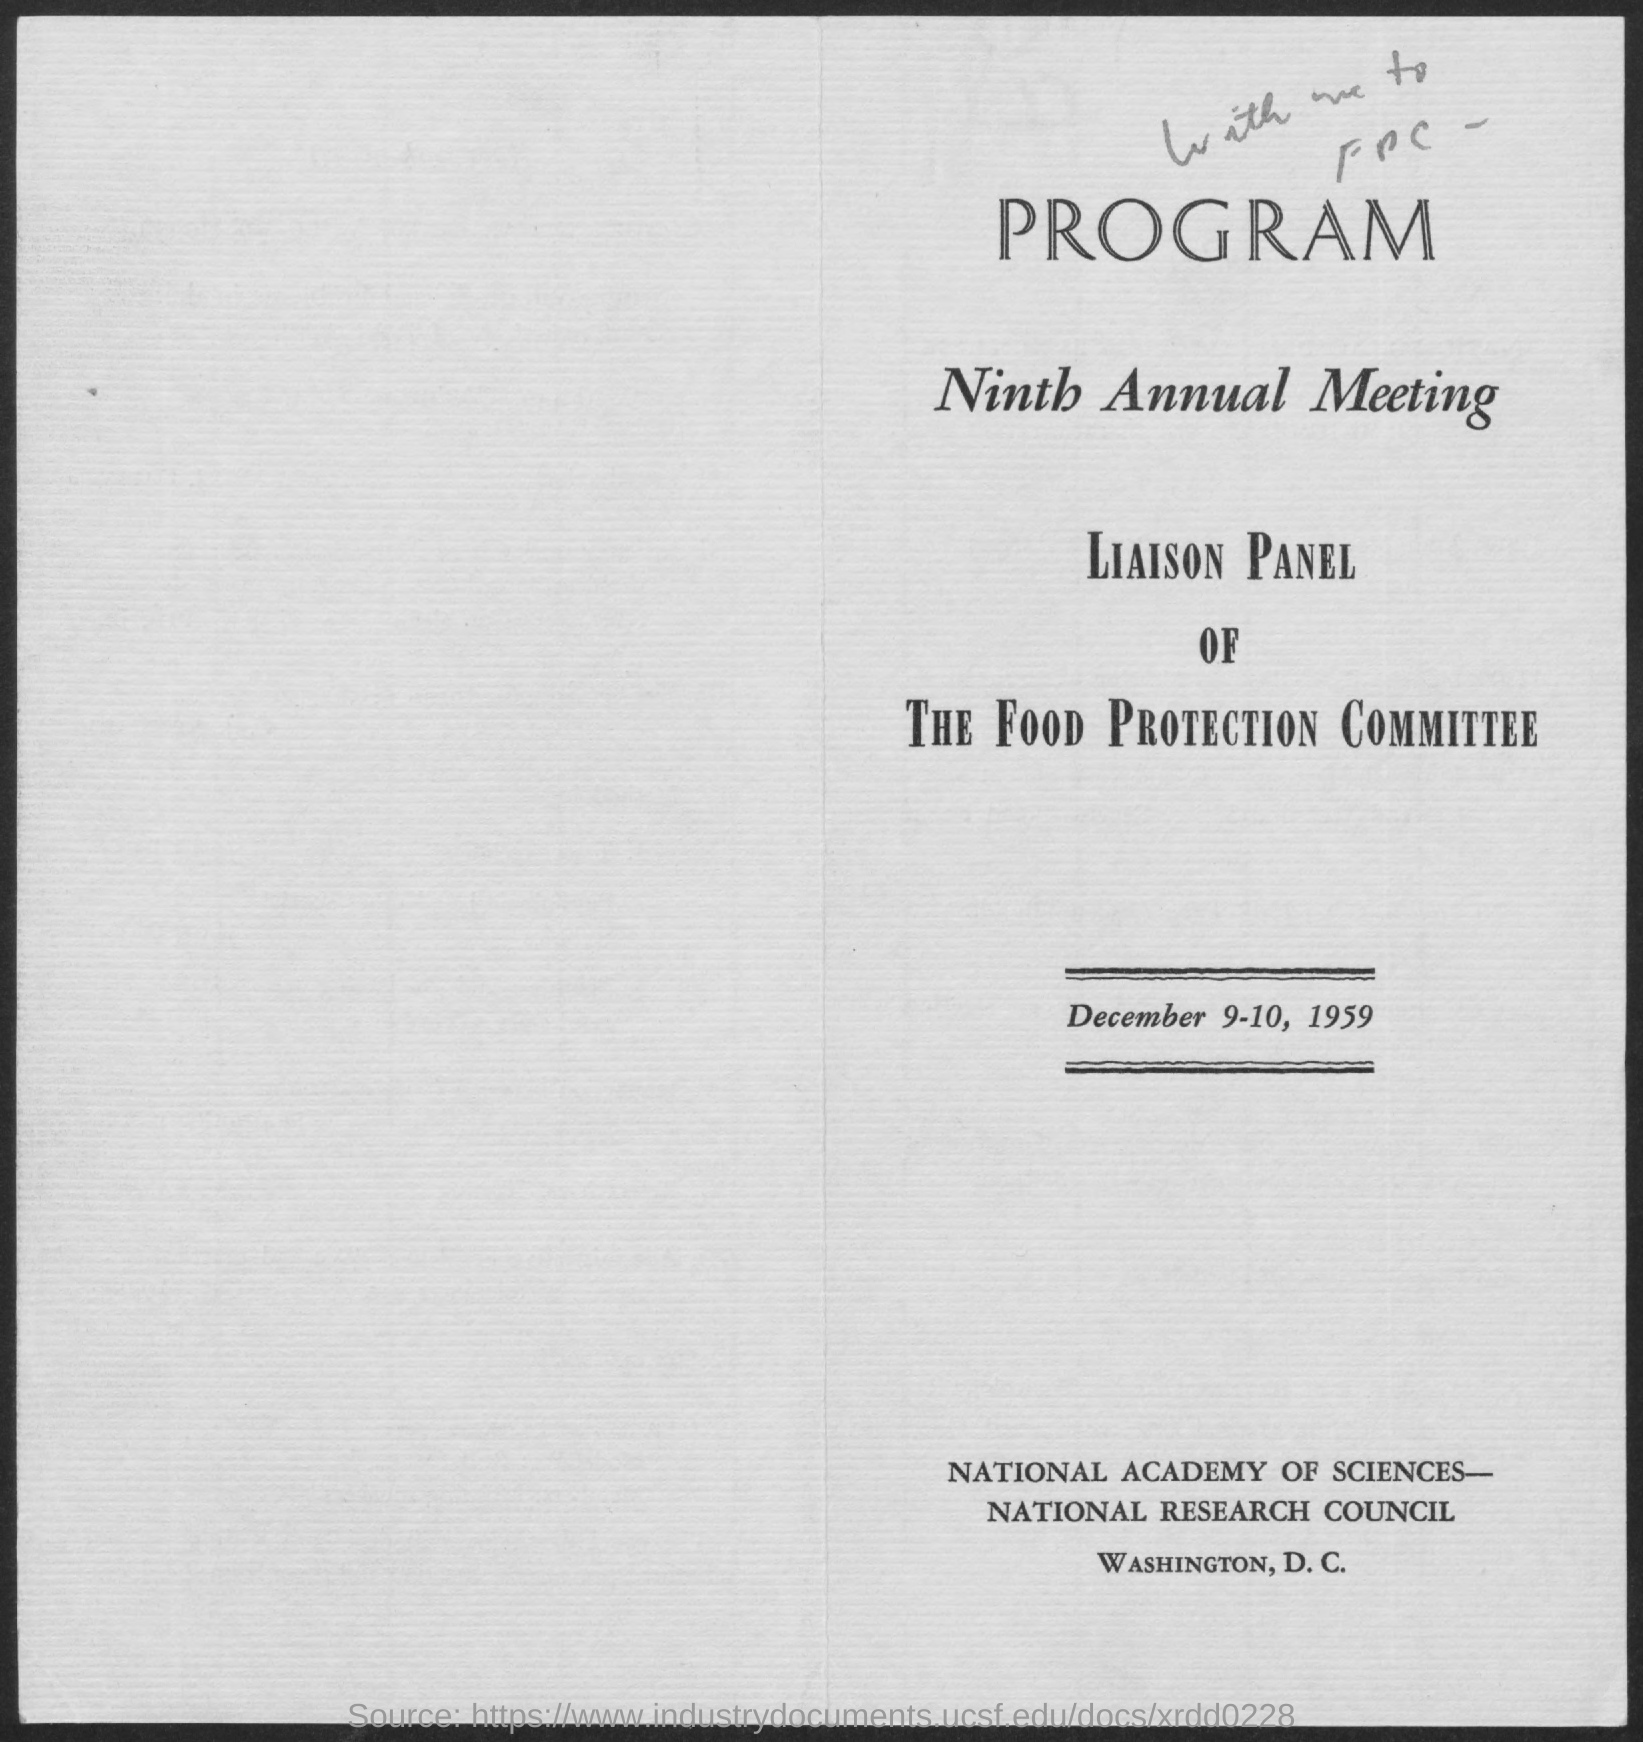Outline some significant characteristics in this image. The ninth annual meeting of the liaison panel of the food protection committee was held on December 9-10, 1959. 